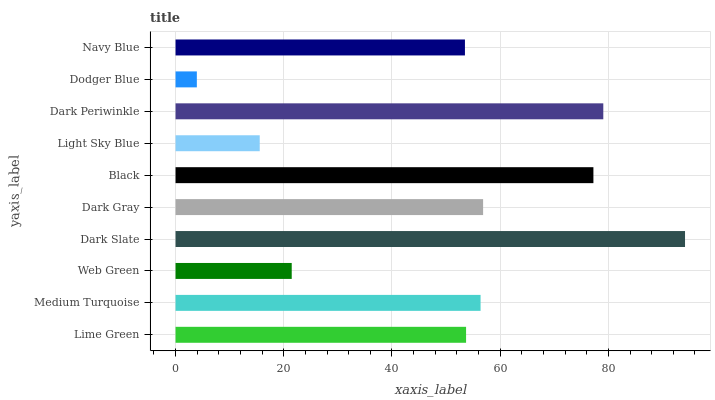Is Dodger Blue the minimum?
Answer yes or no. Yes. Is Dark Slate the maximum?
Answer yes or no. Yes. Is Medium Turquoise the minimum?
Answer yes or no. No. Is Medium Turquoise the maximum?
Answer yes or no. No. Is Medium Turquoise greater than Lime Green?
Answer yes or no. Yes. Is Lime Green less than Medium Turquoise?
Answer yes or no. Yes. Is Lime Green greater than Medium Turquoise?
Answer yes or no. No. Is Medium Turquoise less than Lime Green?
Answer yes or no. No. Is Medium Turquoise the high median?
Answer yes or no. Yes. Is Lime Green the low median?
Answer yes or no. Yes. Is Light Sky Blue the high median?
Answer yes or no. No. Is Navy Blue the low median?
Answer yes or no. No. 